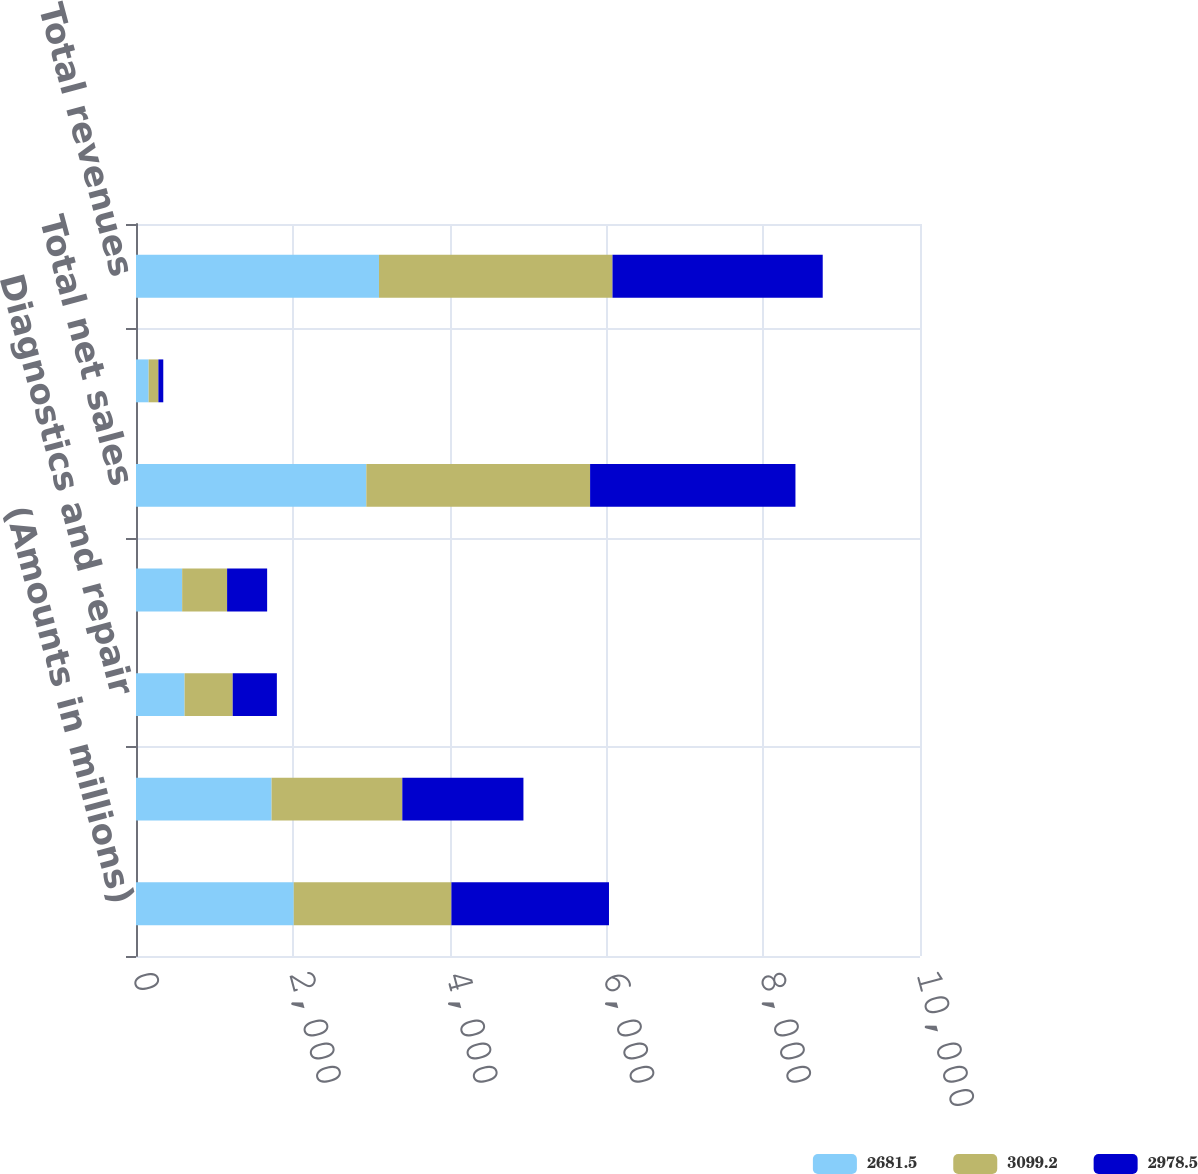Convert chart. <chart><loc_0><loc_0><loc_500><loc_500><stacked_bar_chart><ecel><fcel>(Amounts in millions)<fcel>Tools<fcel>Diagnostics and repair<fcel>Equipment<fcel>Total net sales<fcel>Financial services revenue<fcel>Total revenues<nl><fcel>2681.5<fcel>2012<fcel>1729.4<fcel>619.8<fcel>588.7<fcel>2937.9<fcel>161.3<fcel>3099.2<nl><fcel>3099.2<fcel>2011<fcel>1667.3<fcel>613.7<fcel>573.2<fcel>2854.2<fcel>124.3<fcel>2978.5<nl><fcel>2978.5<fcel>2010<fcel>1545.1<fcel>563.3<fcel>510.8<fcel>2619.2<fcel>62.3<fcel>2681.5<nl></chart> 